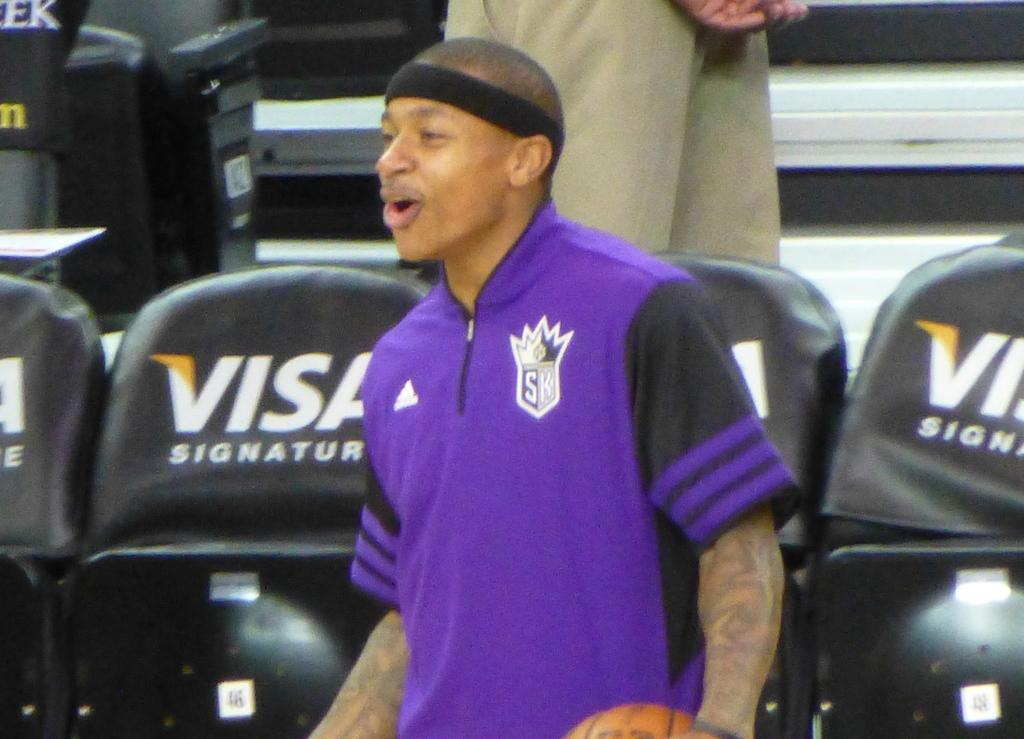<image>
Present a compact description of the photo's key features. A basketball player stands next to chairs embedded with the text VISA SIGNATURE. 